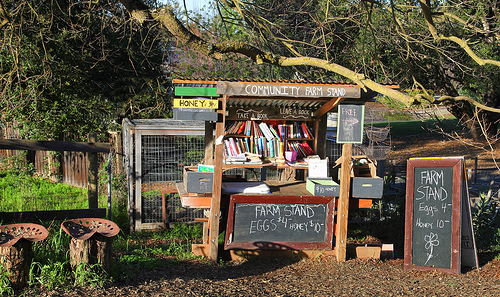<image>
Can you confirm if the branch is on the shop? Yes. Looking at the image, I can see the branch is positioned on top of the shop, with the shop providing support. 